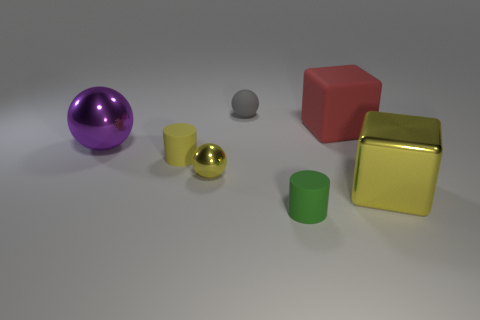Subtract all purple shiny balls. How many balls are left? 2 Subtract 1 balls. How many balls are left? 2 Add 2 large shiny spheres. How many objects exist? 9 Subtract all red cubes. How many cubes are left? 1 Subtract all cyan spheres. Subtract all red blocks. How many spheres are left? 3 Subtract 0 brown cylinders. How many objects are left? 7 Subtract all blocks. How many objects are left? 5 Subtract all big blue metal objects. Subtract all tiny green rubber things. How many objects are left? 6 Add 5 large cubes. How many large cubes are left? 7 Add 7 tiny yellow cylinders. How many tiny yellow cylinders exist? 8 